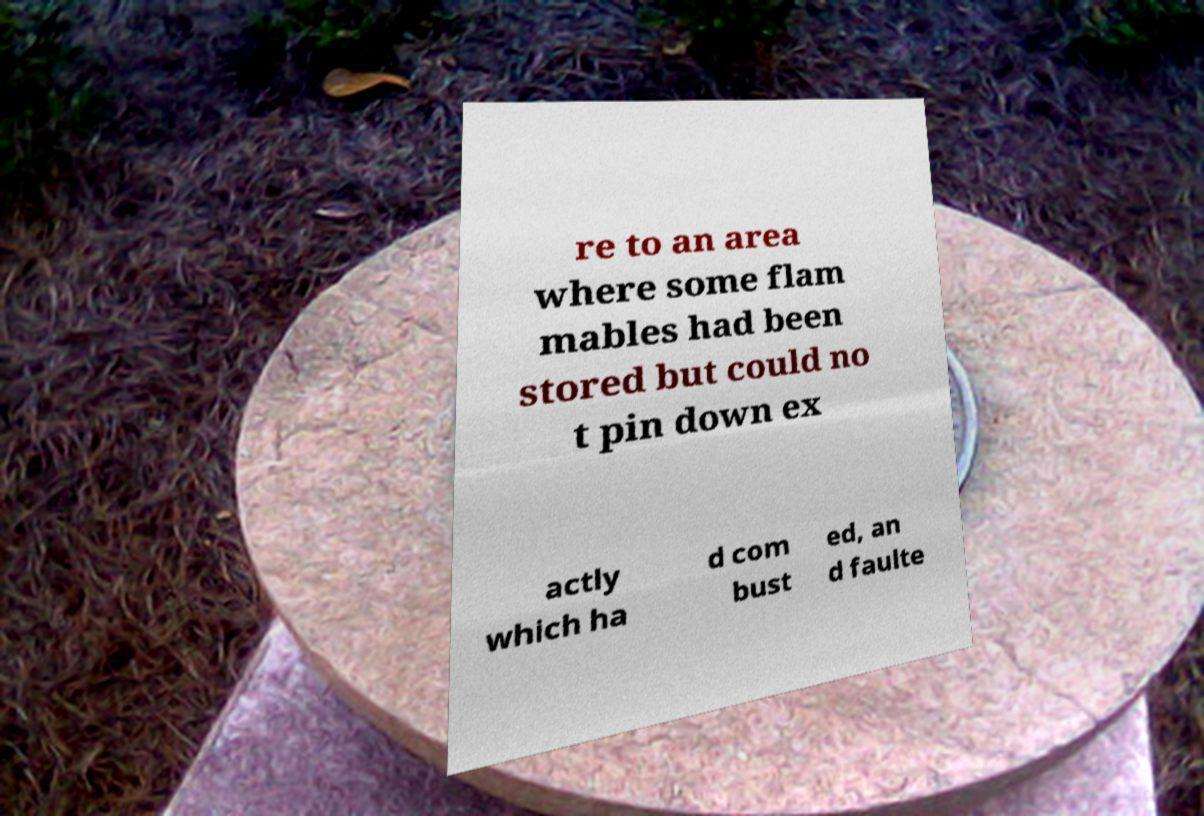Could you assist in decoding the text presented in this image and type it out clearly? re to an area where some flam mables had been stored but could no t pin down ex actly which ha d com bust ed, an d faulte 